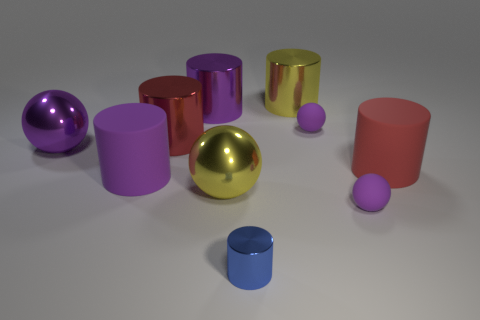Which object in this image stands out the most and why? The object that stands out the most is the centrally placed golden sphere. Its reflective surface captures the light most prominently, drawing the eye with its brightness and central position amongst the other objects. Its perfect spherical shape contrasts with the cylindrical forms around it, making it a focal point in this collection. 